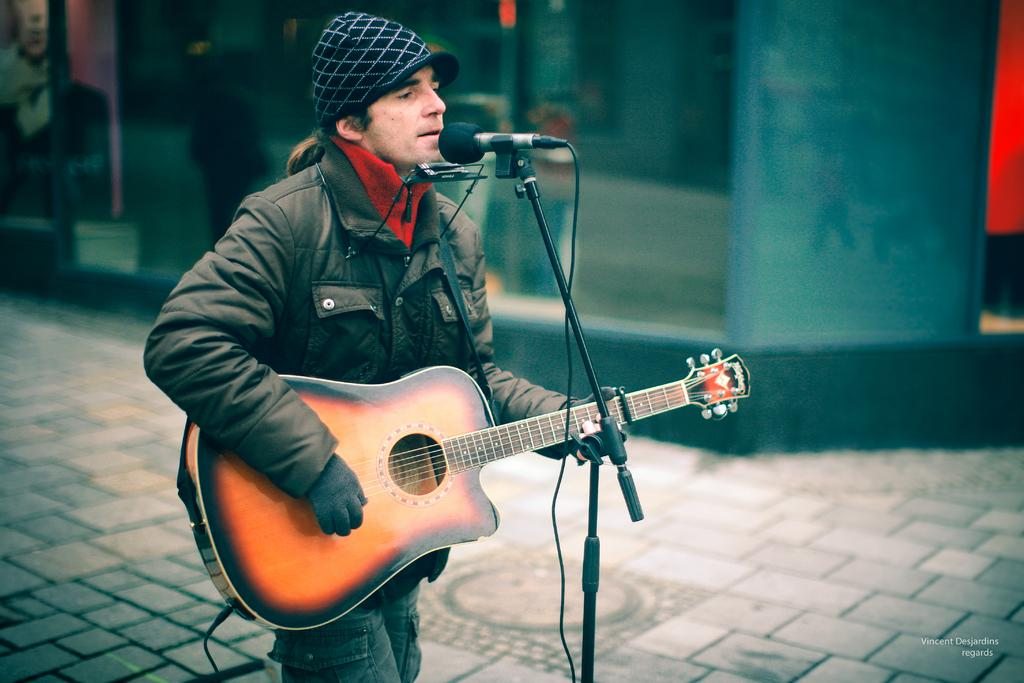What is the man in the image doing? The man is playing a guitar and appears to be singing. What object is in front of the man? There is a microphone in front of the man. What can be seen in the background of the image? There is a store in the background of the image. What type of religious ceremony is taking place in the image? There is no indication of a religious ceremony in the image; the man is playing a guitar and singing, and there is a store in the background. What unit of measurement is being used to determine the man's vocal range? There is no information about the man's vocal range or any unit of measurement being used in the image. 